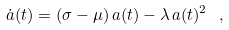<formula> <loc_0><loc_0><loc_500><loc_500>\dot { a } ( t ) = \left ( \sigma - \mu \right ) a ( t ) - \lambda \, a ( t ) ^ { 2 } \ ,</formula> 